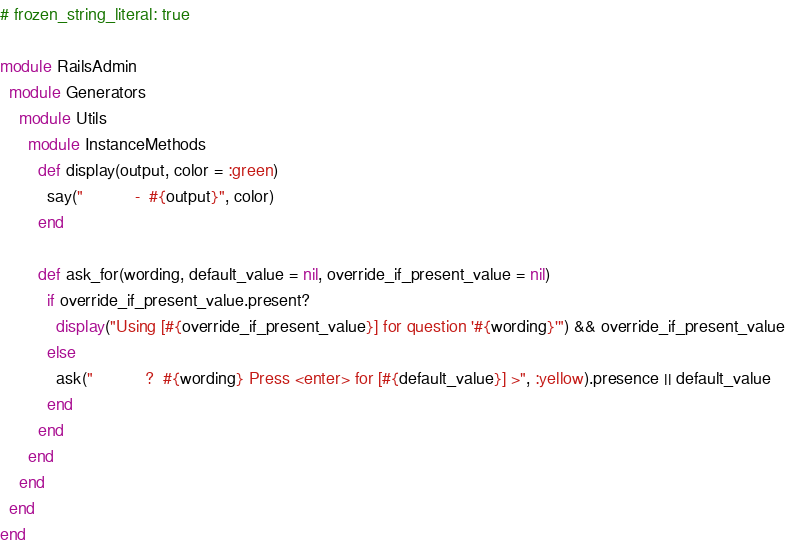Convert code to text. <code><loc_0><loc_0><loc_500><loc_500><_Ruby_># frozen_string_literal: true

module RailsAdmin
  module Generators
    module Utils
      module InstanceMethods
        def display(output, color = :green)
          say("           -  #{output}", color)
        end

        def ask_for(wording, default_value = nil, override_if_present_value = nil)
          if override_if_present_value.present?
            display("Using [#{override_if_present_value}] for question '#{wording}'") && override_if_present_value
          else
            ask("           ?  #{wording} Press <enter> for [#{default_value}] >", :yellow).presence || default_value
          end
        end
      end
    end
  end
end
</code> 